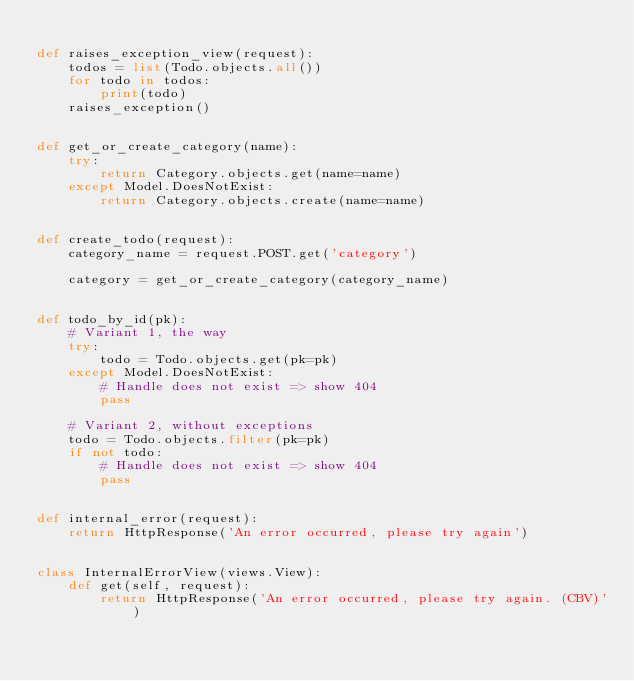Convert code to text. <code><loc_0><loc_0><loc_500><loc_500><_Python_>
def raises_exception_view(request):
    todos = list(Todo.objects.all())
    for todo in todos:
        print(todo)
    raises_exception()


def get_or_create_category(name):
    try:
        return Category.objects.get(name=name)
    except Model.DoesNotExist:
        return Category.objects.create(name=name)


def create_todo(request):
    category_name = request.POST.get('category')

    category = get_or_create_category(category_name)


def todo_by_id(pk):
    # Variant 1, the way
    try:
        todo = Todo.objects.get(pk=pk)
    except Model.DoesNotExist:
        # Handle does not exist => show 404
        pass

    # Variant 2, without exceptions
    todo = Todo.objects.filter(pk=pk)
    if not todo:
        # Handle does not exist => show 404
        pass


def internal_error(request):
    return HttpResponse('An error occurred, please try again')


class InternalErrorView(views.View):
    def get(self, request):
        return HttpResponse('An error occurred, please try again. (CBV)')
</code> 